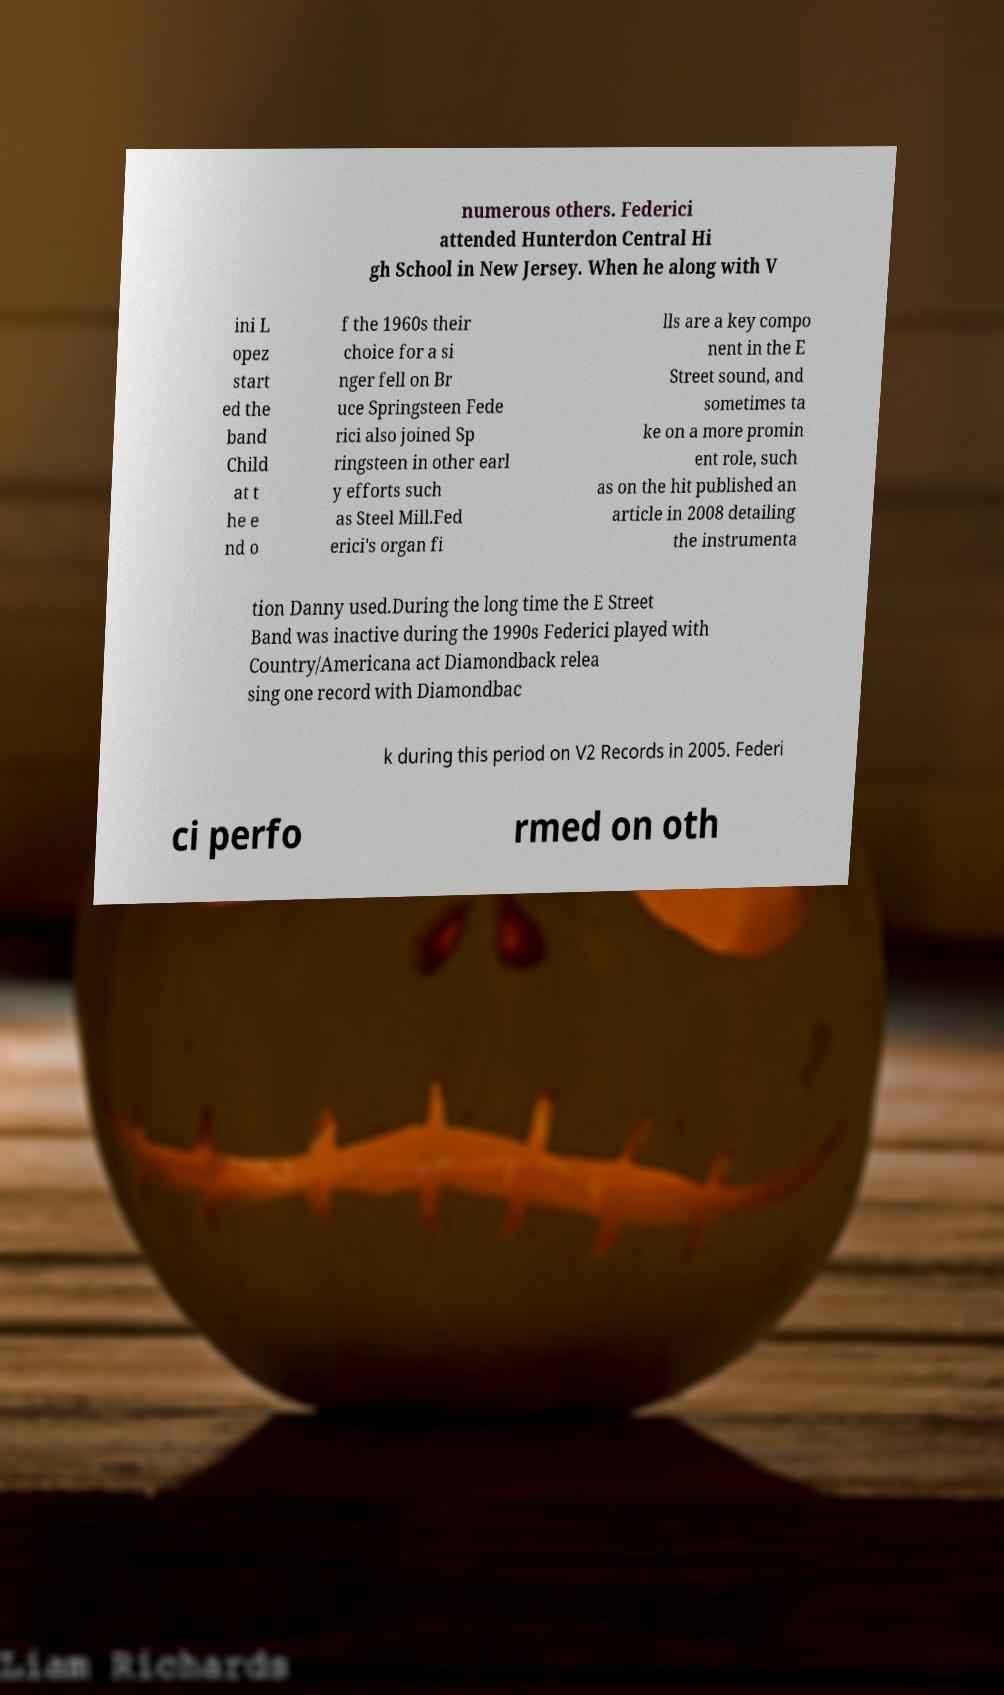For documentation purposes, I need the text within this image transcribed. Could you provide that? numerous others. Federici attended Hunterdon Central Hi gh School in New Jersey. When he along with V ini L opez start ed the band Child at t he e nd o f the 1960s their choice for a si nger fell on Br uce Springsteen Fede rici also joined Sp ringsteen in other earl y efforts such as Steel Mill.Fed erici's organ fi lls are a key compo nent in the E Street sound, and sometimes ta ke on a more promin ent role, such as on the hit published an article in 2008 detailing the instrumenta tion Danny used.During the long time the E Street Band was inactive during the 1990s Federici played with Country/Americana act Diamondback relea sing one record with Diamondbac k during this period on V2 Records in 2005. Federi ci perfo rmed on oth 